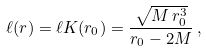<formula> <loc_0><loc_0><loc_500><loc_500>\ell ( r ) = \ell K ( r _ { 0 } ) = \frac { \sqrt { M \, r _ { 0 } ^ { 3 } } } { r _ { 0 } - 2 M } \, ,</formula> 